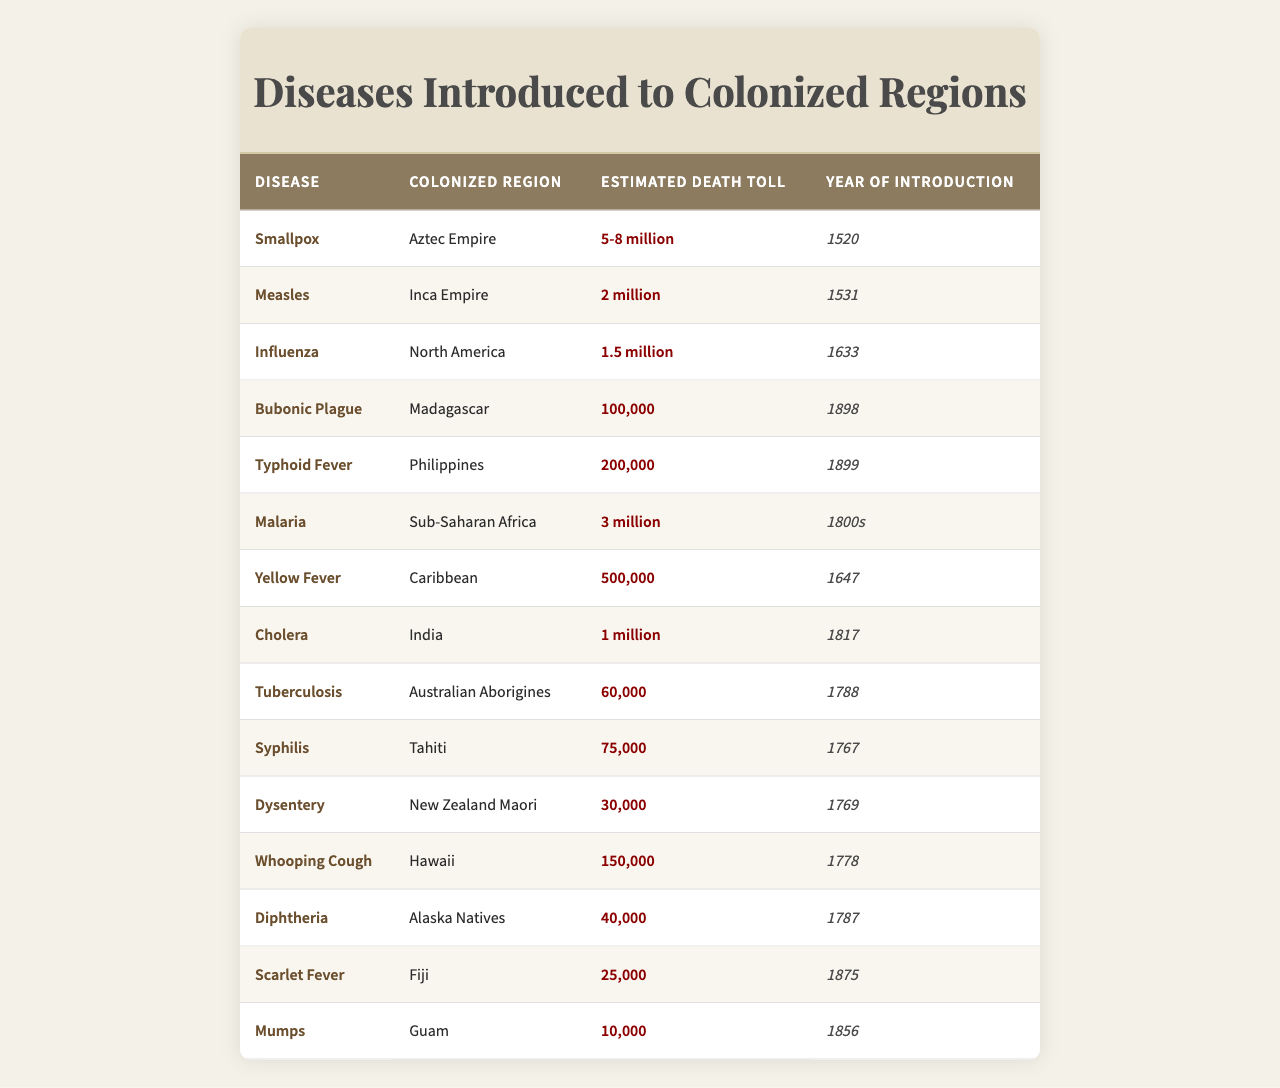What disease had the highest estimated death toll? The table shows that Smallpox had an estimated death toll of 5-8 million, which is the highest compared to all other diseases listed.
Answer: Smallpox In which year was Malaria introduced to Sub-Saharan Africa? According to the table, Malaria was introduced to Sub-Saharan Africa in the 1800s.
Answer: 1800s What is the estimated death toll of Measles in the Inca Empire? The table states that the estimated death toll of Measles in the Inca Empire was 2 million.
Answer: 2 million How many diseases listed affected regions in the Americas? The table shows 6 diseases that affected regions in the Americas: Influenza, Yellow Fever, Whooping Cough, Syphilis, and Smallpox.
Answer: 6 What is the total estimated death toll from Cholera and Typhoid Fever? The table shows that Cholera had an estimated death toll of 1 million and Typhoid Fever had 200,000. Adding these gives 1,000,000 + 200,000 = 1,200,000.
Answer: 1,200,000 Did any disease introduced to colonized regions have an estimated death toll of less than 100,000? Referring to the table, the lowest reported death toll is for Scarlet Fever in Fiji, at 25,000, which is indeed less than 100,000.
Answer: Yes What is the difference in estimated death toll between Smallpox and Yellow Fever? The estimated death toll for Smallpox ranges from 5-8 million and for Yellow Fever, it is 500,000. Taking an estimate of the lowest for Smallpox, the difference is 5,000,000 - 500,000 = 4,500,000.
Answer: 4,500,000 Which disease had an estimated death toll closest to 100,000? Looking at the table, Typhoid Fever with 200,000 has the closest estimated death toll to 100,000.
Answer: Typhoid Fever What was the estimated death toll for Tuberculosis among Australian Aborigines? The table indicates that the estimated death toll for Tuberculosis among Australian Aborigines was 60,000.
Answer: 60,000 Which region experienced the introduction of Syphilis, and what was its death toll? The table states that Syphilis was introduced to Tahiti, with an estimated death toll of 75,000.
Answer: Tahiti, 75,000 